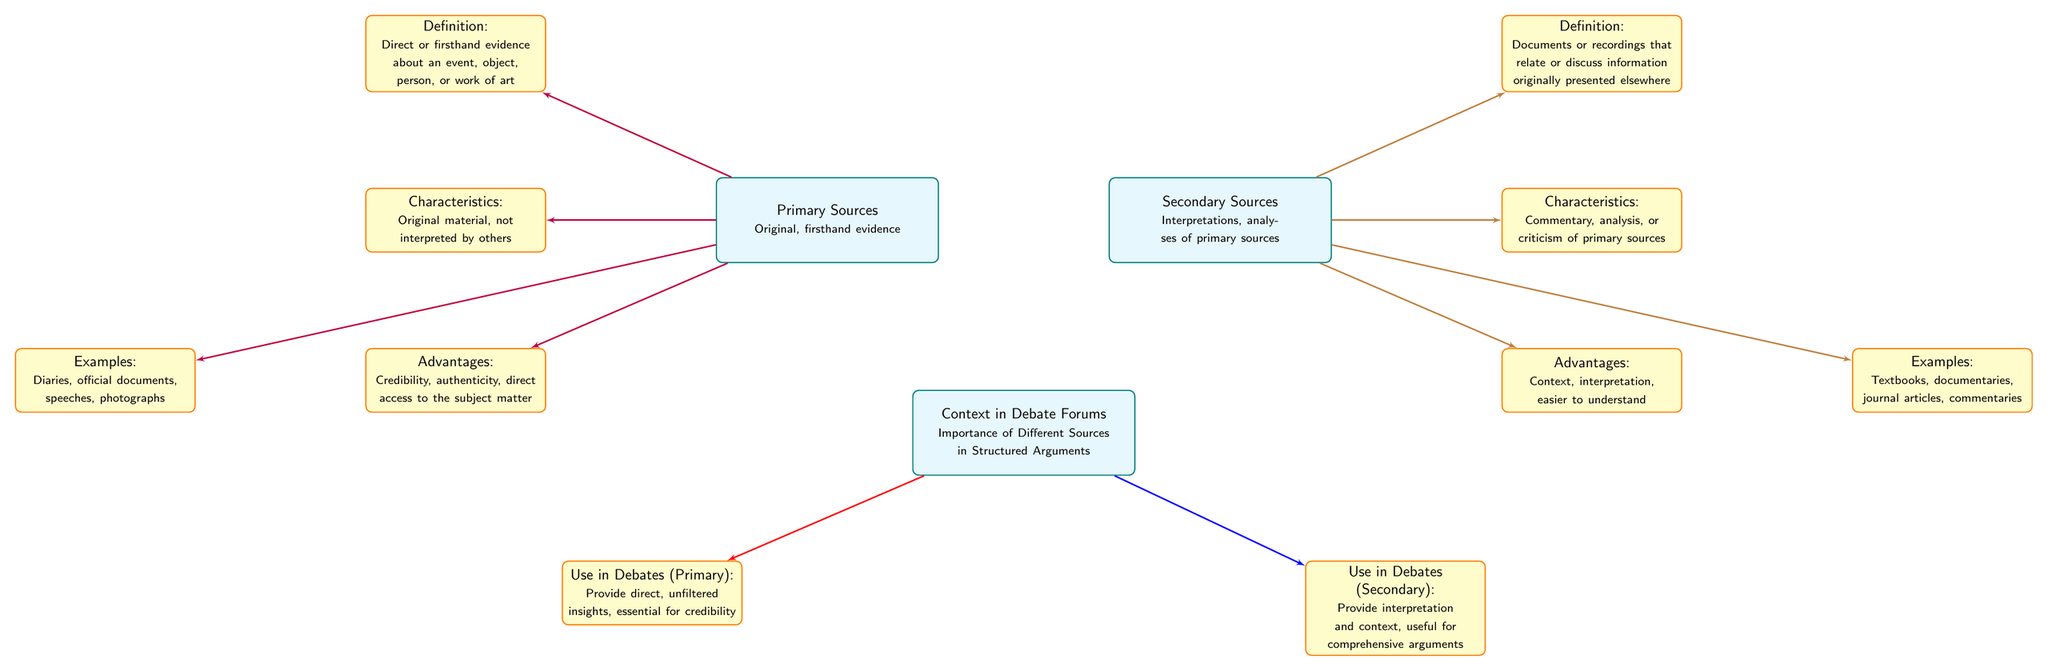What is the definition of primary sources? The diagram states that primary sources are defined as "Direct or firsthand evidence about an event, object, person, or work of art." This is directly mentioned in the section about primary sources.
Answer: Direct or firsthand evidence about an event, object, person, or work of art What are examples of secondary sources? The diagram lists textbooks, documentaries, journal articles, and commentaries as examples of secondary sources. This is found in the section that discusses the advantages and examples of secondary sources.
Answer: Textbooks, documentaries, journal articles, commentaries How many total advantages are listed for both primary and secondary sources? The diagram provides two advantages each for primary and secondary sources. Therefore, to find the total, we can add these together: 2 (primary) + 2 (secondary) equals 4.
Answer: 4 What is the main characteristic of primary sources? According to the diagram, primary sources have the characteristic of being "Original material, not interpreted by others." This characteristic highlights their unmediated nature.
Answer: Original material, not interpreted by others What is the use of primary sources in debates? The diagram indicates that the use of primary sources in debates is to "Provide direct, unfiltered insights, essential for credibility." This is noted in the context section regarding their application in debate forums.
Answer: Provide direct, unfiltered insights, essential for credibility How do secondary sources contribute to debate arguments? The diagram states that secondary sources contribute to debate arguments by providing "interpretation and context, useful for comprehensive arguments." This shows their role in enriching discussions.
Answer: Interpretation and context, useful for comprehensive arguments What color represents the lines connecting primary sources to their characteristics? The diagram indicates that the lines connecting primary sources to details like definition, characteristics, advantages, and examples are colored purple. This can be observed throughout the primary sources section.
Answer: Purple Which type of sources is defined as "Interpretations, analyses of primary sources"? The diagram clearly defines secondary sources as "Interpretations, analyses of primary sources." This description is found in the section dedicated to secondary sources.
Answer: Interpretations, analyses of primary sources 